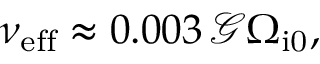Convert formula to latex. <formula><loc_0><loc_0><loc_500><loc_500>\nu _ { e f f } \approx 0 . 0 0 3 \, \mathcal { G } \Omega _ { i 0 } ,</formula> 